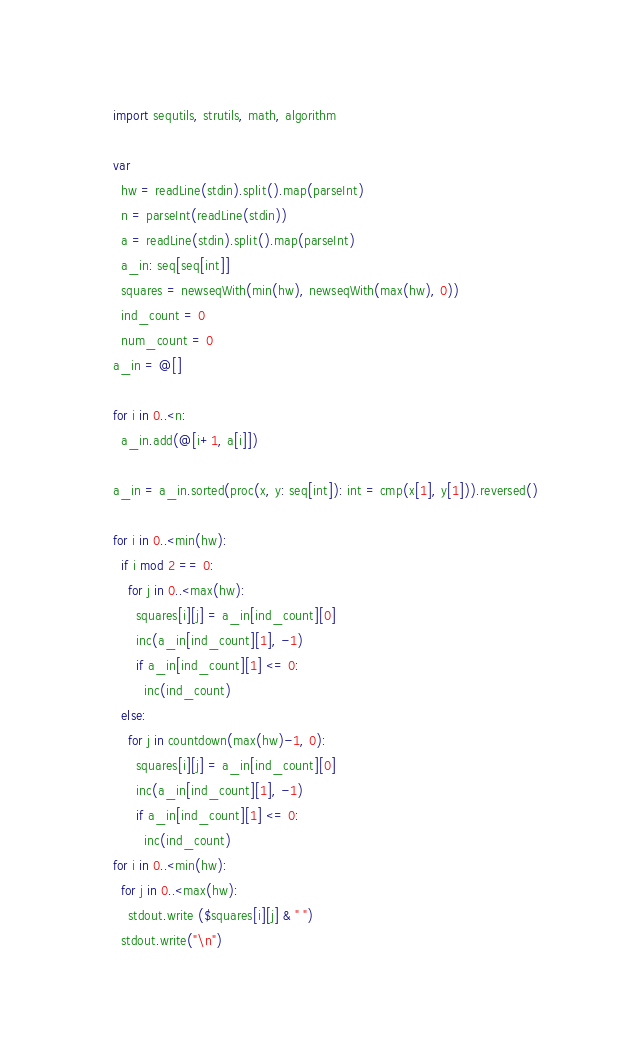<code> <loc_0><loc_0><loc_500><loc_500><_Nim_>import sequtils, strutils, math, algorithm

var
  hw = readLine(stdin).split().map(parseInt)
  n = parseInt(readLine(stdin))
  a = readLine(stdin).split().map(parseInt)
  a_in: seq[seq[int]]
  squares = newseqWith(min(hw), newseqWith(max(hw), 0))
  ind_count = 0
  num_count = 0
a_in = @[]

for i in 0..<n:
  a_in.add(@[i+1, a[i]])

a_in = a_in.sorted(proc(x, y: seq[int]): int = cmp(x[1], y[1])).reversed()

for i in 0..<min(hw):
  if i mod 2 == 0:
    for j in 0..<max(hw):
      squares[i][j] = a_in[ind_count][0]
      inc(a_in[ind_count][1], -1)
      if a_in[ind_count][1] <= 0:
        inc(ind_count)
  else:
    for j in countdown(max(hw)-1, 0):
      squares[i][j] = a_in[ind_count][0]
      inc(a_in[ind_count][1], -1)
      if a_in[ind_count][1] <= 0:
        inc(ind_count)
for i in 0..<min(hw):
  for j in 0..<max(hw):
    stdout.write ($squares[i][j] & " ")
  stdout.write("\n")</code> 